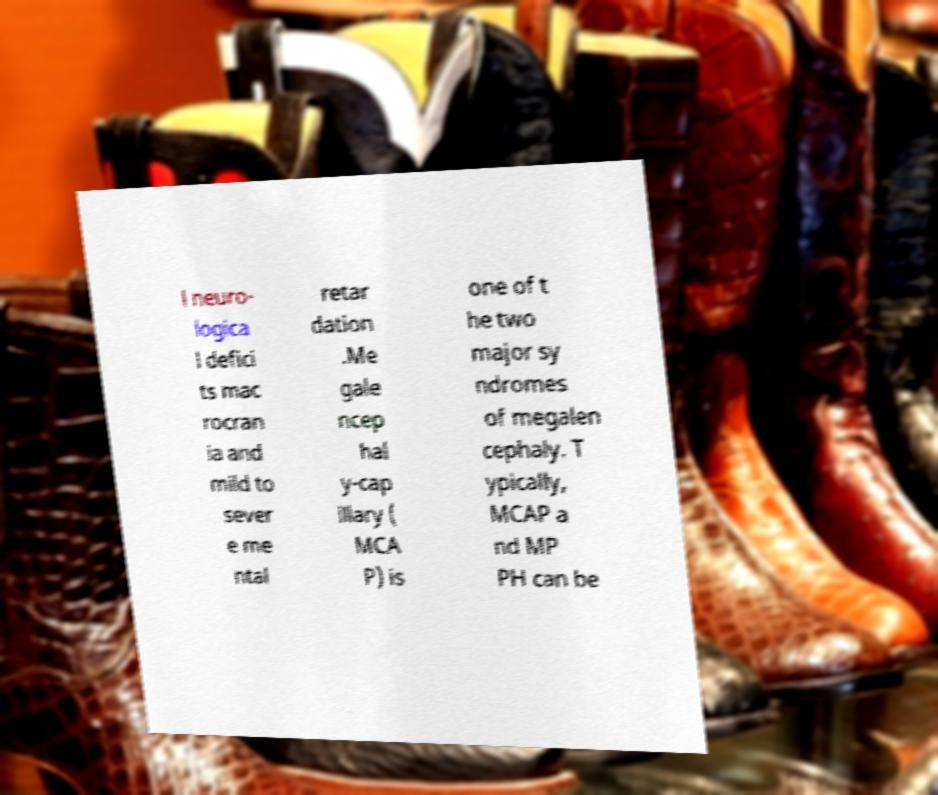Could you extract and type out the text from this image? l neuro- logica l defici ts mac rocran ia and mild to sever e me ntal retar dation .Me gale ncep hal y-cap illary ( MCA P) is one of t he two major sy ndromes of megalen cephaly. T ypically, MCAP a nd MP PH can be 